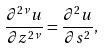<formula> <loc_0><loc_0><loc_500><loc_500>\frac { \partial ^ { 2 \nu } u } { \partial z ^ { 2 \nu } } = \frac { \partial ^ { 2 } u } { \partial s ^ { 2 } } ,</formula> 